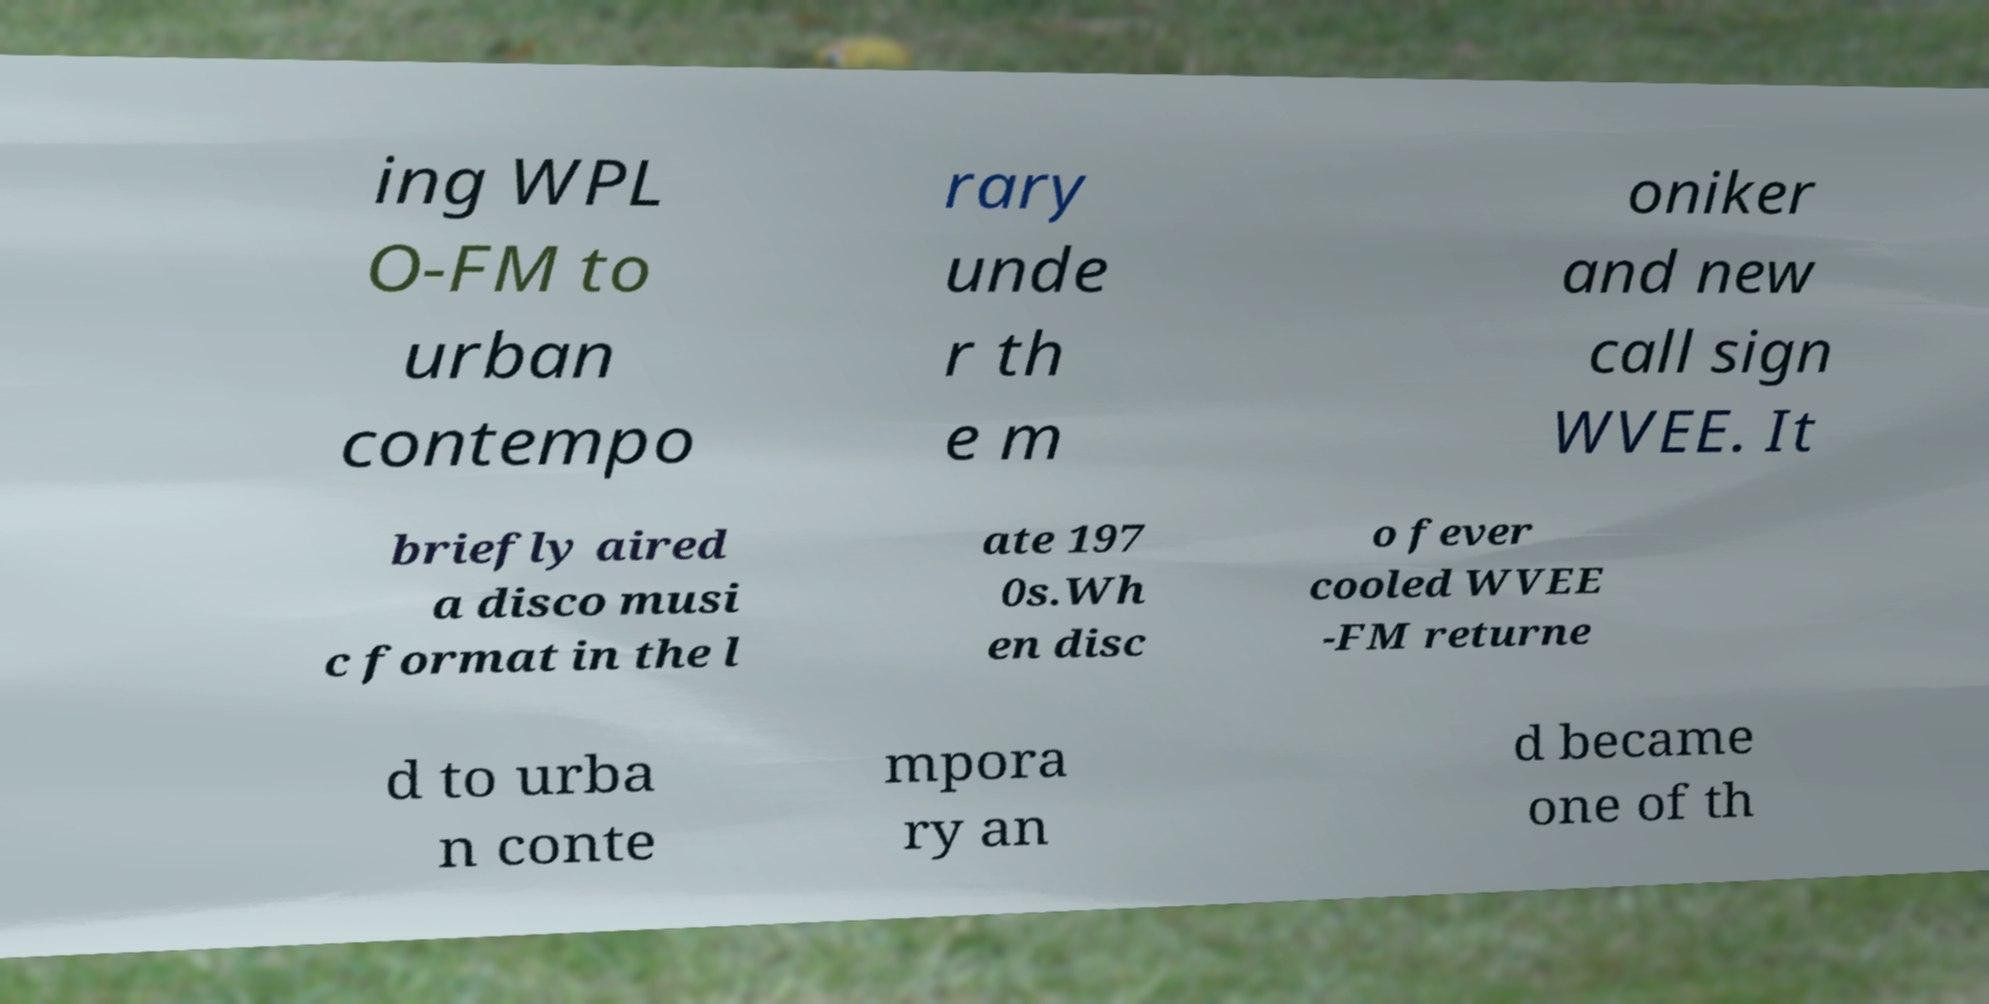Could you extract and type out the text from this image? ing WPL O-FM to urban contempo rary unde r th e m oniker and new call sign WVEE. It briefly aired a disco musi c format in the l ate 197 0s.Wh en disc o fever cooled WVEE -FM returne d to urba n conte mpora ry an d became one of th 